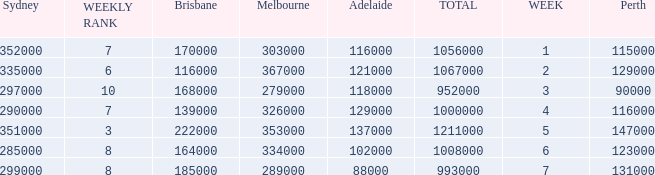How many viewers were there in Sydney for the episode when there were 334000 in Melbourne? 285000.0. 